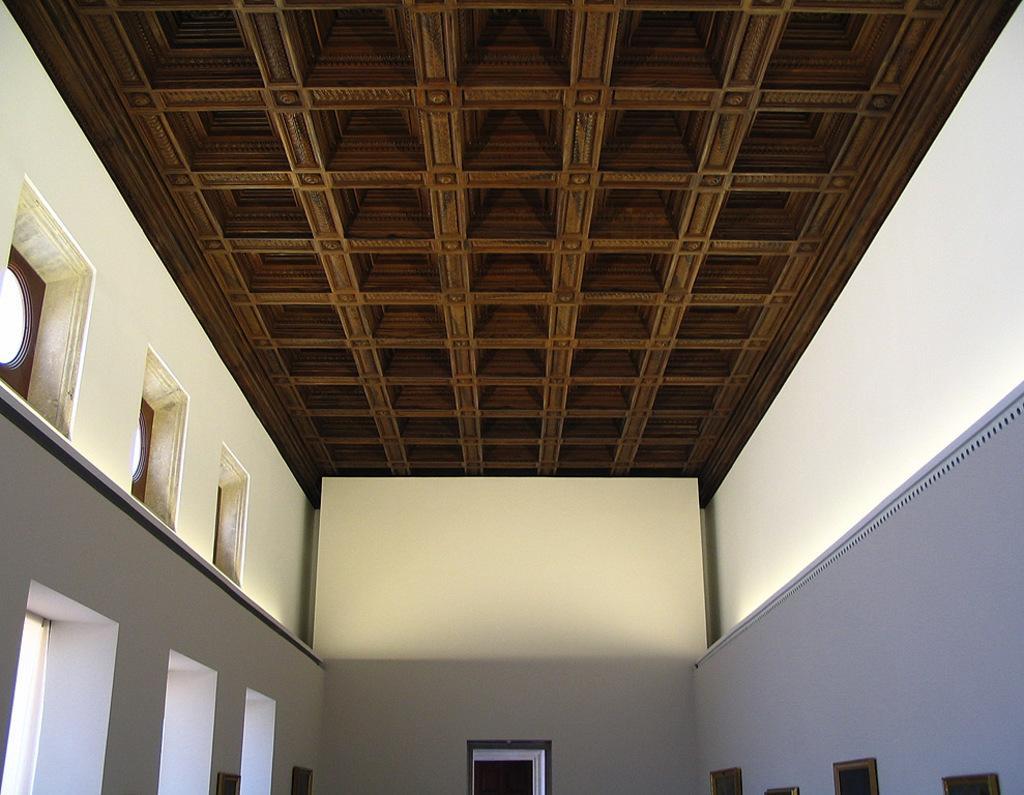In one or two sentences, can you explain what this image depicts? In the picture I can see the glass ventilation windows on the top left side of the picture. These are looking like photo frames on the wall on the bottom right side. I can see the roof of the house at the top of the picture. I can see a glass window on the bottom left side. 